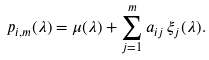<formula> <loc_0><loc_0><loc_500><loc_500>p _ { i , m } ( \lambda ) = \mu ( \lambda ) + \sum _ { j = 1 } ^ { m } a _ { i j } \, \xi _ { j } ( \lambda ) .</formula> 